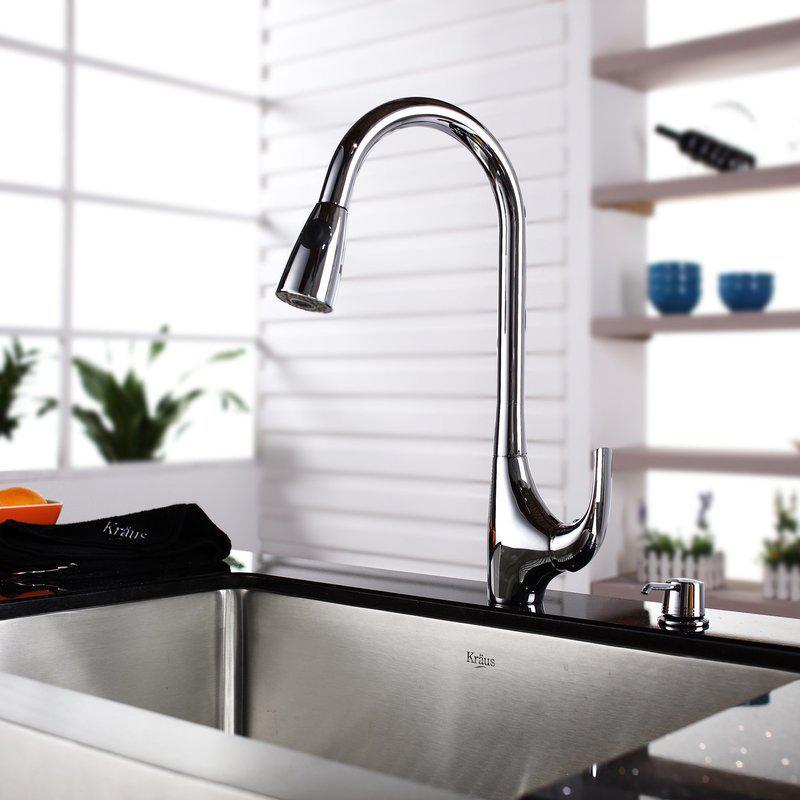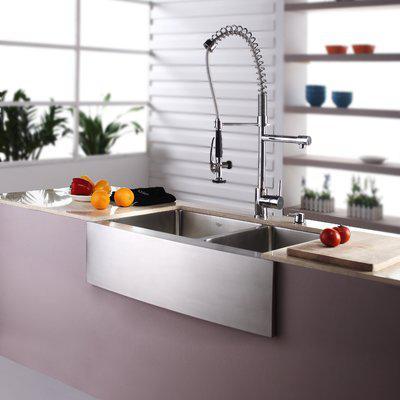The first image is the image on the left, the second image is the image on the right. Analyze the images presented: Is the assertion "The right image shows a single-basin rectangular sink with a wire rack inside it." valid? Answer yes or no. No. 